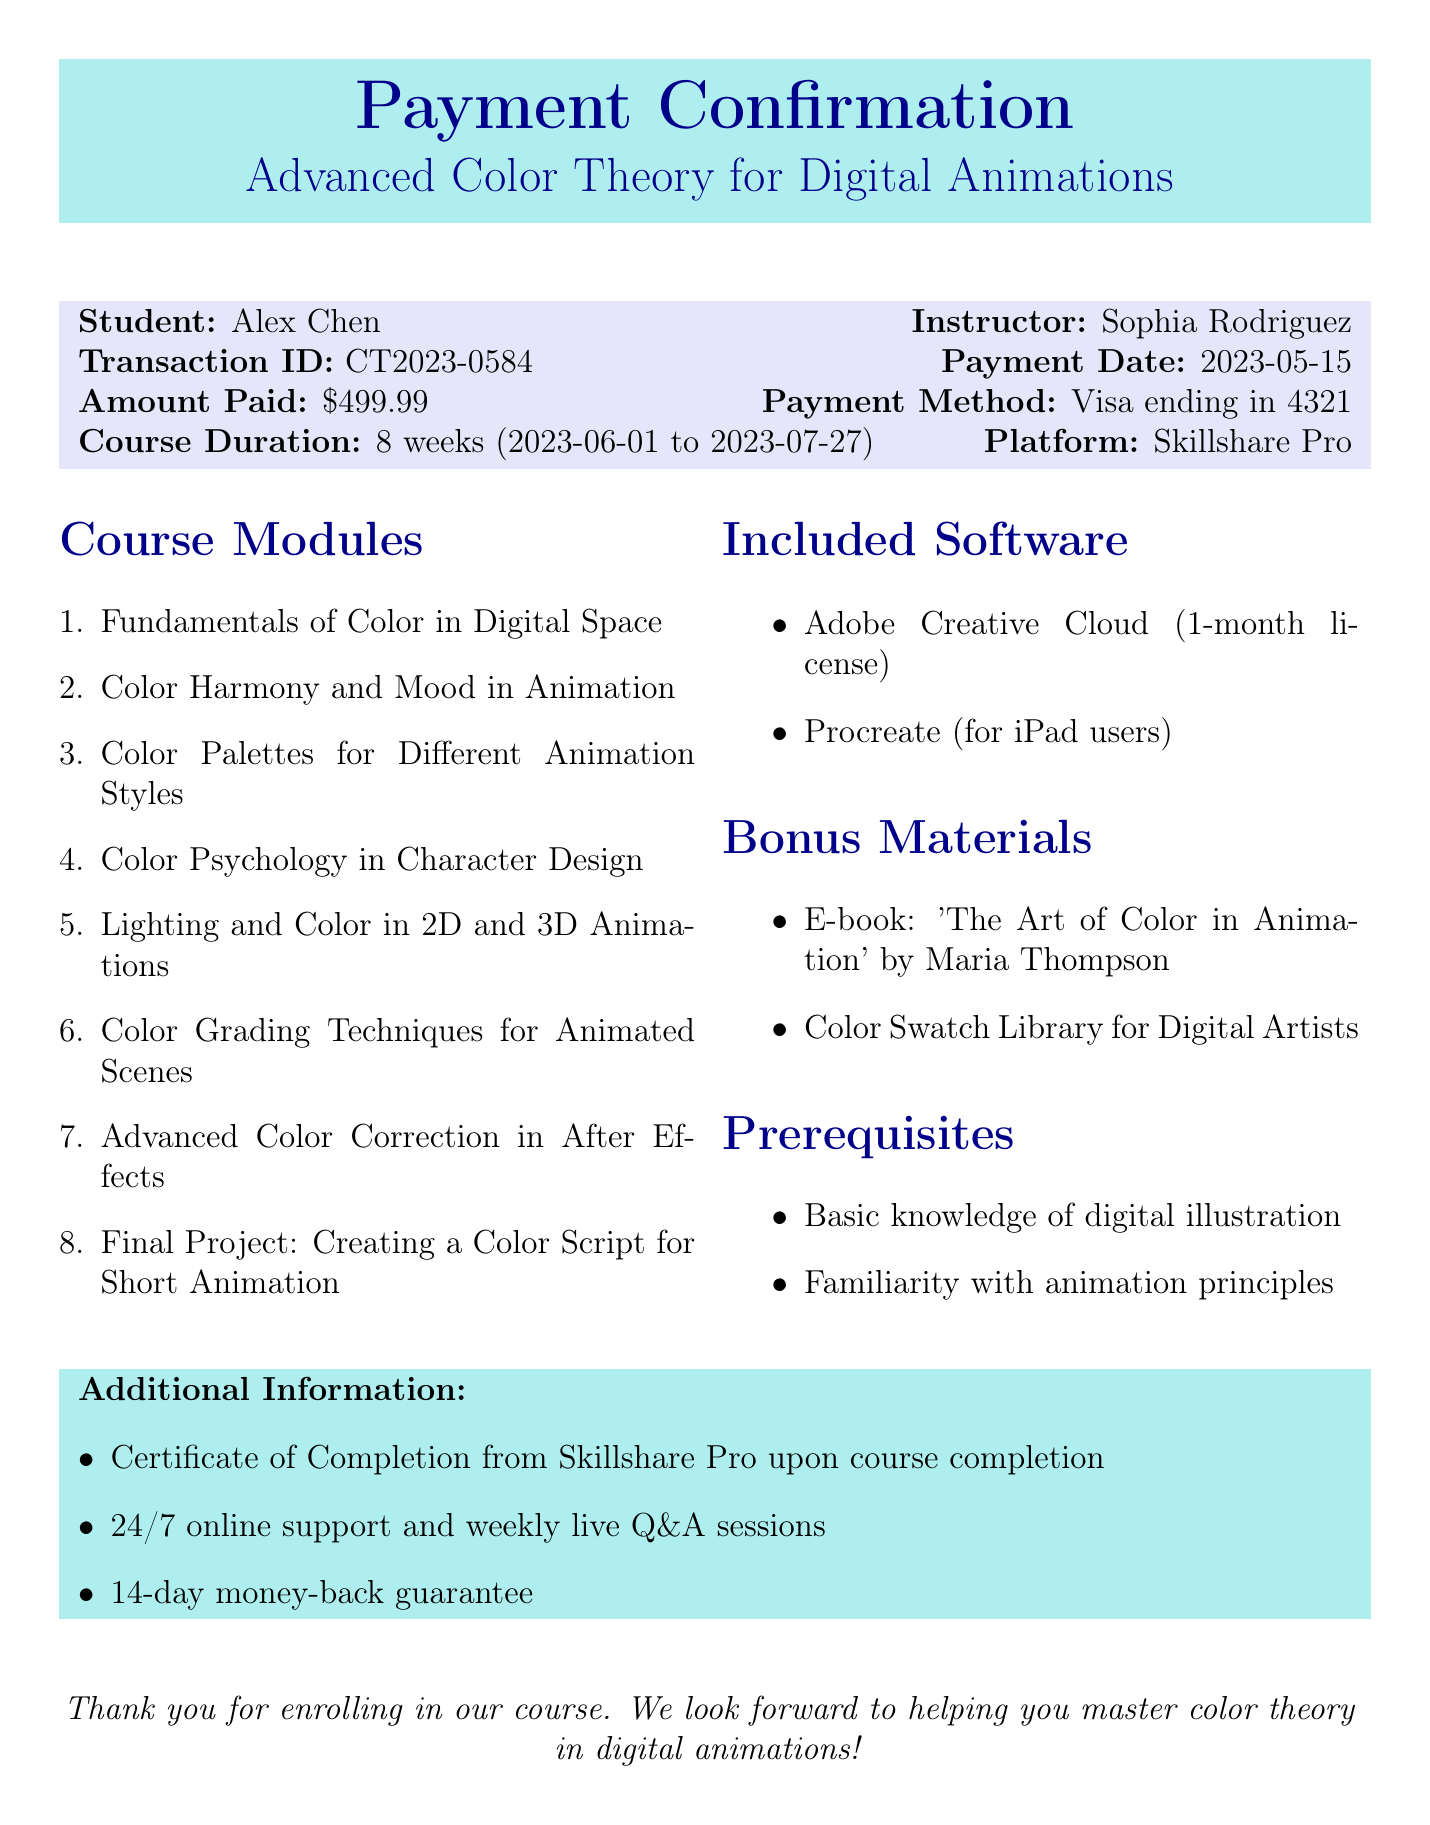What is the course name? The course name is stated clearly in the document's header as "Advanced Color Theory for Digital Animations."
Answer: Advanced Color Theory for Digital Animations Who is the instructor? The instructor's name is mentioned alongside the student in the transaction details.
Answer: Sophia Rodriguez What is the payment amount? The document specifies the payment amount directly under payment details.
Answer: $499.99 What is the transaction ID? The transaction ID is provided in the document's transaction information section.
Answer: CT2023-0584 What is the course duration? The course duration is explicitly mentioned in the payment confirmation details.
Answer: 8 weeks How many modules are included in the course? The document lists a total of eight modules under the Course Modules section.
Answer: 8 What type of support is offered? The document describes 24/7 online support and weekly live Q&A sessions as part of the course support.
Answer: 24/7 online support What are the prerequisites for the course? The prerequisites are listed to set expectations for the student before starting the course.
Answer: Basic knowledge of digital illustration, Familiarity with animation principles What is the refund policy? The document includes the refund policy clearly at the end of the confirmation.
Answer: 14-day money-back guarantee What is included with the course software? The document provides information about included software, and it mentions Adobe Creative Cloud and Procreate.
Answer: Adobe Creative Cloud, Procreate 